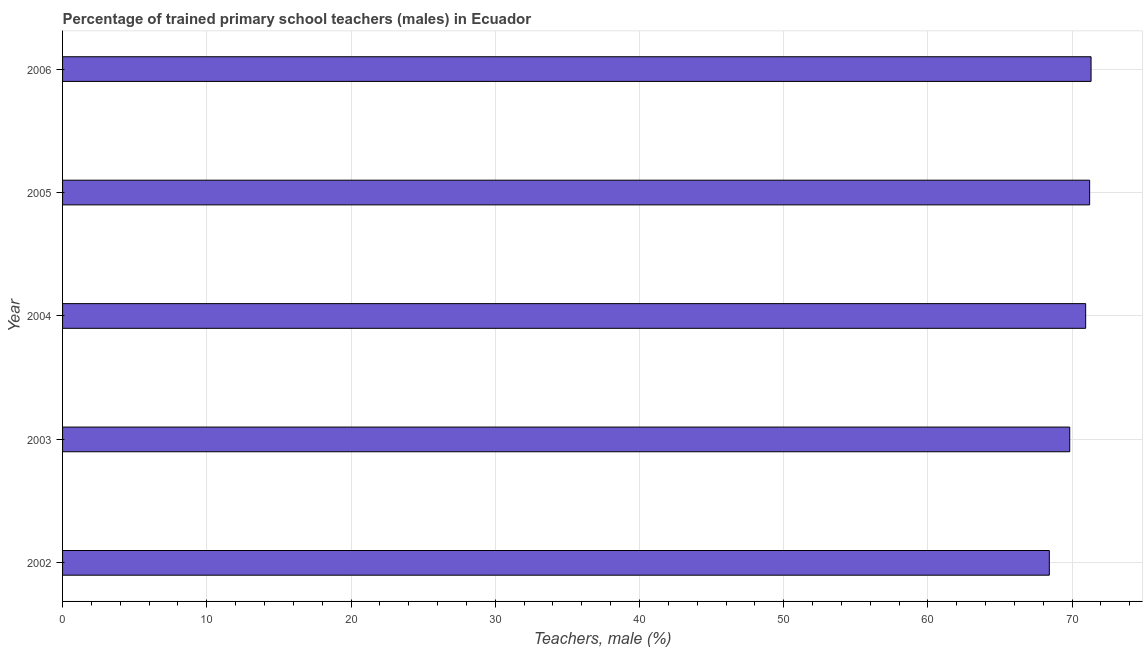Does the graph contain grids?
Provide a short and direct response. Yes. What is the title of the graph?
Your response must be concise. Percentage of trained primary school teachers (males) in Ecuador. What is the label or title of the X-axis?
Make the answer very short. Teachers, male (%). What is the label or title of the Y-axis?
Your answer should be very brief. Year. What is the percentage of trained male teachers in 2005?
Give a very brief answer. 71.21. Across all years, what is the maximum percentage of trained male teachers?
Provide a short and direct response. 71.31. Across all years, what is the minimum percentage of trained male teachers?
Offer a very short reply. 68.42. What is the sum of the percentage of trained male teachers?
Offer a very short reply. 351.72. What is the difference between the percentage of trained male teachers in 2002 and 2006?
Your answer should be compact. -2.89. What is the average percentage of trained male teachers per year?
Ensure brevity in your answer.  70.34. What is the median percentage of trained male teachers?
Provide a succinct answer. 70.94. What is the ratio of the percentage of trained male teachers in 2003 to that in 2004?
Provide a succinct answer. 0.98. Is the percentage of trained male teachers in 2002 less than that in 2005?
Provide a short and direct response. Yes. What is the difference between the highest and the second highest percentage of trained male teachers?
Provide a succinct answer. 0.1. Is the sum of the percentage of trained male teachers in 2002 and 2006 greater than the maximum percentage of trained male teachers across all years?
Offer a terse response. Yes. What is the difference between the highest and the lowest percentage of trained male teachers?
Your answer should be compact. 2.89. In how many years, is the percentage of trained male teachers greater than the average percentage of trained male teachers taken over all years?
Your answer should be compact. 3. Are all the bars in the graph horizontal?
Make the answer very short. Yes. What is the difference between two consecutive major ticks on the X-axis?
Offer a very short reply. 10. What is the Teachers, male (%) of 2002?
Your answer should be very brief. 68.42. What is the Teachers, male (%) in 2003?
Your answer should be compact. 69.83. What is the Teachers, male (%) of 2004?
Ensure brevity in your answer.  70.94. What is the Teachers, male (%) in 2005?
Make the answer very short. 71.21. What is the Teachers, male (%) of 2006?
Give a very brief answer. 71.31. What is the difference between the Teachers, male (%) in 2002 and 2003?
Ensure brevity in your answer.  -1.41. What is the difference between the Teachers, male (%) in 2002 and 2004?
Your answer should be very brief. -2.52. What is the difference between the Teachers, male (%) in 2002 and 2005?
Keep it short and to the point. -2.79. What is the difference between the Teachers, male (%) in 2002 and 2006?
Offer a terse response. -2.89. What is the difference between the Teachers, male (%) in 2003 and 2004?
Keep it short and to the point. -1.1. What is the difference between the Teachers, male (%) in 2003 and 2005?
Your answer should be very brief. -1.38. What is the difference between the Teachers, male (%) in 2003 and 2006?
Provide a short and direct response. -1.48. What is the difference between the Teachers, male (%) in 2004 and 2005?
Ensure brevity in your answer.  -0.28. What is the difference between the Teachers, male (%) in 2004 and 2006?
Keep it short and to the point. -0.37. What is the difference between the Teachers, male (%) in 2005 and 2006?
Your answer should be very brief. -0.1. What is the ratio of the Teachers, male (%) in 2002 to that in 2004?
Offer a terse response. 0.96. What is the ratio of the Teachers, male (%) in 2002 to that in 2006?
Provide a short and direct response. 0.96. What is the ratio of the Teachers, male (%) in 2003 to that in 2004?
Your answer should be compact. 0.98. What is the ratio of the Teachers, male (%) in 2004 to that in 2006?
Your answer should be compact. 0.99. 